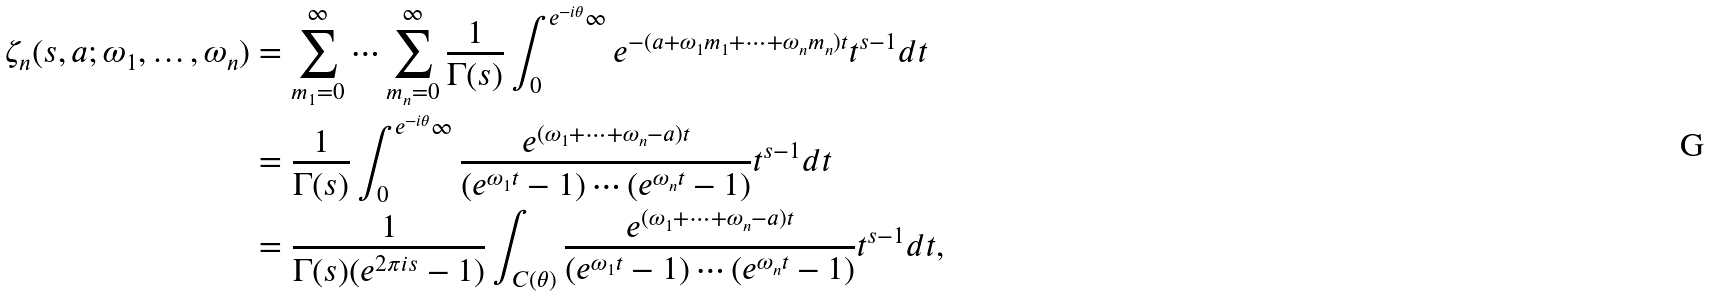Convert formula to latex. <formula><loc_0><loc_0><loc_500><loc_500>\zeta _ { n } ( s , a ; \omega _ { 1 } , \dots , \omega _ { n } ) & = \sum _ { m _ { 1 } = 0 } ^ { \infty } \cdots \sum _ { m _ { n } = 0 } ^ { \infty } \frac { 1 } { \Gamma ( s ) } \int _ { 0 } ^ { e ^ { - i \theta } \infty } e ^ { - ( a + \omega _ { 1 } m _ { 1 } + \cdots + \omega _ { n } m _ { n } ) t } t ^ { s - 1 } d t \\ & = \frac { 1 } { \Gamma ( s ) } \int _ { 0 } ^ { e ^ { - i \theta } \infty } \frac { e ^ { ( \omega _ { 1 } + \cdots + \omega _ { n } - a ) t } } { ( e ^ { \omega _ { 1 } t } - 1 ) \cdots ( e ^ { \omega _ { n } t } - 1 ) } t ^ { s - 1 } d t \\ & = \frac { 1 } { \Gamma ( s ) ( e ^ { 2 \pi i s } - 1 ) } \int _ { C ( \theta ) } \frac { e ^ { ( \omega _ { 1 } + \cdots + \omega _ { n } - a ) t } } { ( e ^ { \omega _ { 1 } t } - 1 ) \cdots ( e ^ { \omega _ { n } t } - 1 ) } t ^ { s - 1 } d t ,</formula> 